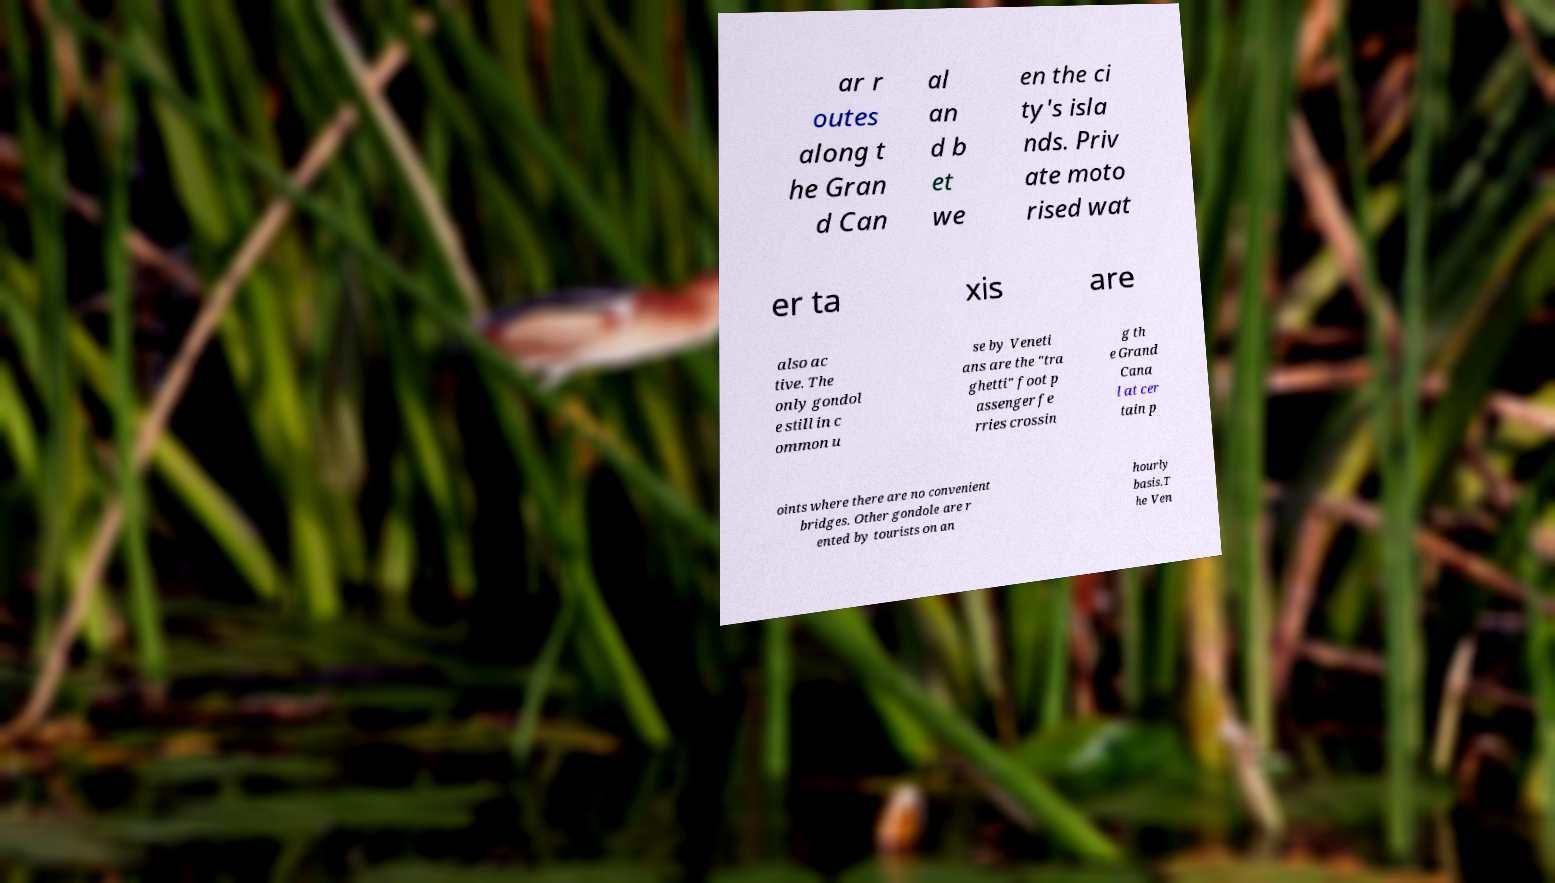Could you extract and type out the text from this image? ar r outes along t he Gran d Can al an d b et we en the ci ty's isla nds. Priv ate moto rised wat er ta xis are also ac tive. The only gondol e still in c ommon u se by Veneti ans are the "tra ghetti" foot p assenger fe rries crossin g th e Grand Cana l at cer tain p oints where there are no convenient bridges. Other gondole are r ented by tourists on an hourly basis.T he Ven 